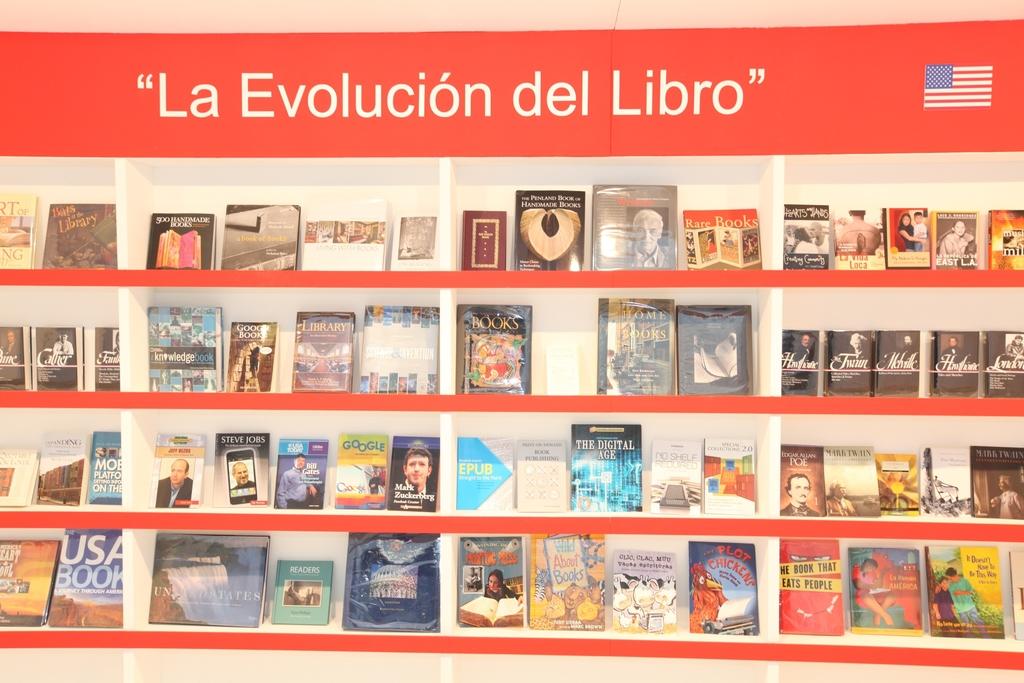What is the phrase at the top of the display?
Offer a very short reply. La evolucion del libro. 